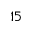Convert formula to latex. <formula><loc_0><loc_0><loc_500><loc_500>1 5</formula> 